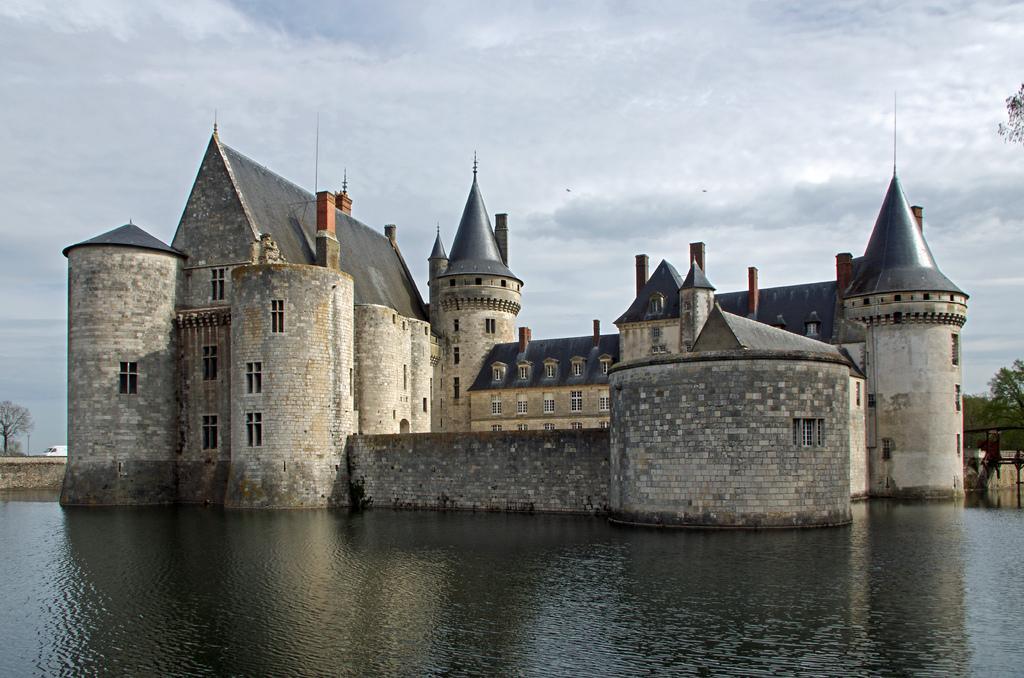How would you summarize this image in a sentence or two? In this image it looks like a castle in the water. At the top there is the sky. In the background there are trees. On the left side there is a wall, Beside the wall there is a tree. There is a van on the road. 